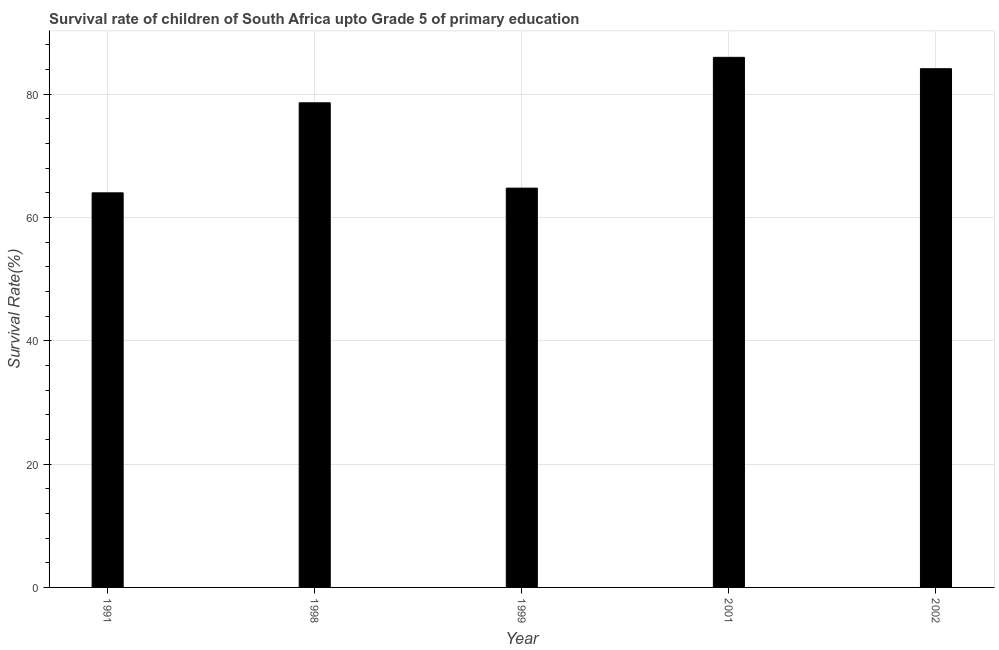Does the graph contain any zero values?
Your response must be concise. No. Does the graph contain grids?
Ensure brevity in your answer.  Yes. What is the title of the graph?
Ensure brevity in your answer.  Survival rate of children of South Africa upto Grade 5 of primary education. What is the label or title of the X-axis?
Provide a succinct answer. Year. What is the label or title of the Y-axis?
Ensure brevity in your answer.  Survival Rate(%). What is the survival rate in 1999?
Your answer should be very brief. 64.76. Across all years, what is the maximum survival rate?
Your response must be concise. 85.97. Across all years, what is the minimum survival rate?
Provide a short and direct response. 64. In which year was the survival rate maximum?
Provide a short and direct response. 2001. In which year was the survival rate minimum?
Keep it short and to the point. 1991. What is the sum of the survival rate?
Your answer should be compact. 377.46. What is the difference between the survival rate in 2001 and 2002?
Offer a terse response. 1.85. What is the average survival rate per year?
Your answer should be very brief. 75.49. What is the median survival rate?
Give a very brief answer. 78.6. In how many years, is the survival rate greater than 76 %?
Your response must be concise. 3. What is the ratio of the survival rate in 1999 to that in 2001?
Offer a very short reply. 0.75. Is the survival rate in 1998 less than that in 2001?
Offer a very short reply. Yes. Is the difference between the survival rate in 2001 and 2002 greater than the difference between any two years?
Your answer should be compact. No. What is the difference between the highest and the second highest survival rate?
Keep it short and to the point. 1.85. What is the difference between the highest and the lowest survival rate?
Provide a short and direct response. 21.98. In how many years, is the survival rate greater than the average survival rate taken over all years?
Keep it short and to the point. 3. Are all the bars in the graph horizontal?
Your answer should be very brief. No. How many years are there in the graph?
Ensure brevity in your answer.  5. What is the difference between two consecutive major ticks on the Y-axis?
Provide a succinct answer. 20. What is the Survival Rate(%) of 1991?
Keep it short and to the point. 64. What is the Survival Rate(%) of 1998?
Your answer should be very brief. 78.6. What is the Survival Rate(%) in 1999?
Give a very brief answer. 64.76. What is the Survival Rate(%) of 2001?
Provide a succinct answer. 85.97. What is the Survival Rate(%) of 2002?
Offer a very short reply. 84.13. What is the difference between the Survival Rate(%) in 1991 and 1998?
Your response must be concise. -14.6. What is the difference between the Survival Rate(%) in 1991 and 1999?
Make the answer very short. -0.76. What is the difference between the Survival Rate(%) in 1991 and 2001?
Offer a terse response. -21.98. What is the difference between the Survival Rate(%) in 1991 and 2002?
Offer a terse response. -20.13. What is the difference between the Survival Rate(%) in 1998 and 1999?
Ensure brevity in your answer.  13.84. What is the difference between the Survival Rate(%) in 1998 and 2001?
Provide a short and direct response. -7.38. What is the difference between the Survival Rate(%) in 1998 and 2002?
Provide a short and direct response. -5.53. What is the difference between the Survival Rate(%) in 1999 and 2001?
Offer a terse response. -21.22. What is the difference between the Survival Rate(%) in 1999 and 2002?
Your answer should be compact. -19.37. What is the difference between the Survival Rate(%) in 2001 and 2002?
Your answer should be compact. 1.85. What is the ratio of the Survival Rate(%) in 1991 to that in 1998?
Make the answer very short. 0.81. What is the ratio of the Survival Rate(%) in 1991 to that in 1999?
Give a very brief answer. 0.99. What is the ratio of the Survival Rate(%) in 1991 to that in 2001?
Ensure brevity in your answer.  0.74. What is the ratio of the Survival Rate(%) in 1991 to that in 2002?
Offer a terse response. 0.76. What is the ratio of the Survival Rate(%) in 1998 to that in 1999?
Your answer should be very brief. 1.21. What is the ratio of the Survival Rate(%) in 1998 to that in 2001?
Keep it short and to the point. 0.91. What is the ratio of the Survival Rate(%) in 1998 to that in 2002?
Your response must be concise. 0.93. What is the ratio of the Survival Rate(%) in 1999 to that in 2001?
Give a very brief answer. 0.75. What is the ratio of the Survival Rate(%) in 1999 to that in 2002?
Your response must be concise. 0.77. 